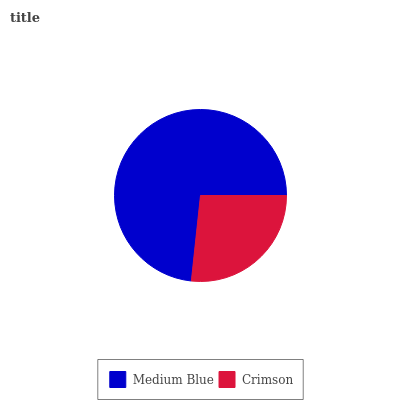Is Crimson the minimum?
Answer yes or no. Yes. Is Medium Blue the maximum?
Answer yes or no. Yes. Is Crimson the maximum?
Answer yes or no. No. Is Medium Blue greater than Crimson?
Answer yes or no. Yes. Is Crimson less than Medium Blue?
Answer yes or no. Yes. Is Crimson greater than Medium Blue?
Answer yes or no. No. Is Medium Blue less than Crimson?
Answer yes or no. No. Is Medium Blue the high median?
Answer yes or no. Yes. Is Crimson the low median?
Answer yes or no. Yes. Is Crimson the high median?
Answer yes or no. No. Is Medium Blue the low median?
Answer yes or no. No. 